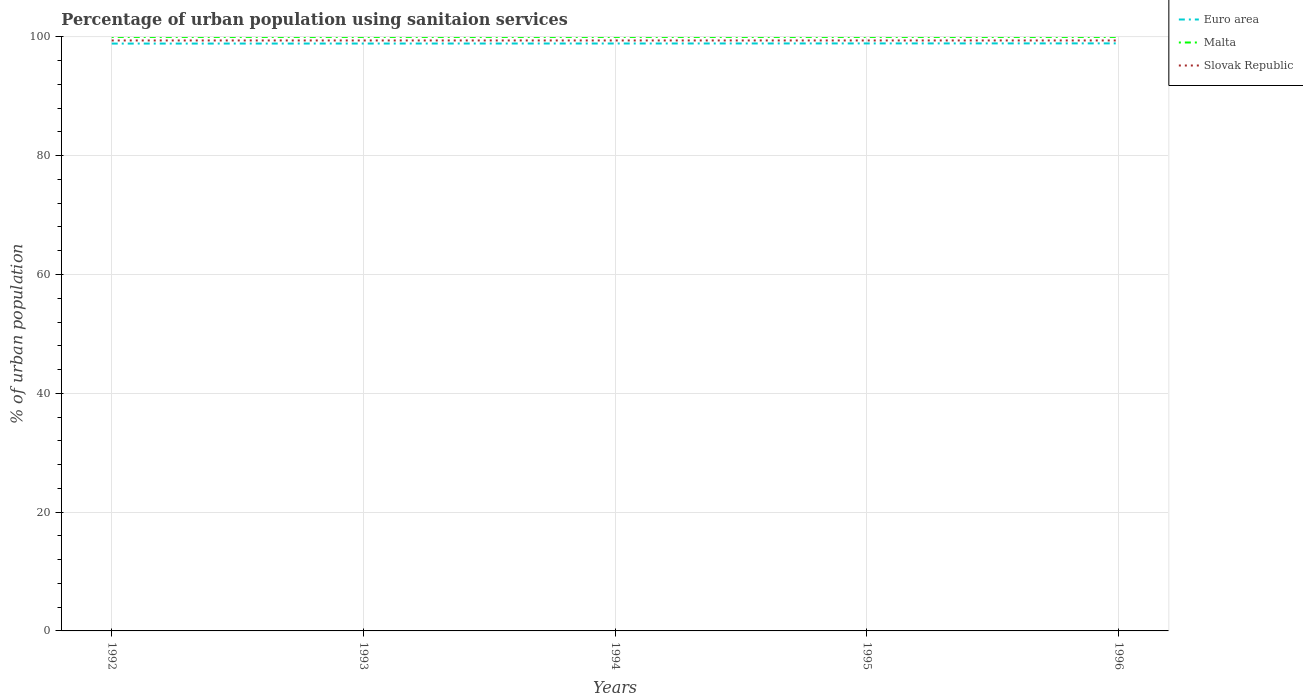Does the line corresponding to Slovak Republic intersect with the line corresponding to Malta?
Ensure brevity in your answer.  No. Across all years, what is the maximum percentage of urban population using sanitaion services in Euro area?
Provide a short and direct response. 98.88. What is the difference between the highest and the lowest percentage of urban population using sanitaion services in Euro area?
Offer a terse response. 2. Is the percentage of urban population using sanitaion services in Euro area strictly greater than the percentage of urban population using sanitaion services in Slovak Republic over the years?
Make the answer very short. Yes. How many years are there in the graph?
Make the answer very short. 5. Are the values on the major ticks of Y-axis written in scientific E-notation?
Offer a terse response. No. Does the graph contain any zero values?
Provide a short and direct response. No. Does the graph contain grids?
Your answer should be very brief. Yes. Where does the legend appear in the graph?
Give a very brief answer. Top right. What is the title of the graph?
Your answer should be compact. Percentage of urban population using sanitaion services. Does "Mauritania" appear as one of the legend labels in the graph?
Give a very brief answer. No. What is the label or title of the X-axis?
Make the answer very short. Years. What is the label or title of the Y-axis?
Ensure brevity in your answer.  % of urban population. What is the % of urban population of Euro area in 1992?
Offer a terse response. 98.88. What is the % of urban population of Slovak Republic in 1992?
Offer a very short reply. 99.4. What is the % of urban population in Euro area in 1993?
Offer a terse response. 98.89. What is the % of urban population of Slovak Republic in 1993?
Your answer should be compact. 99.4. What is the % of urban population of Euro area in 1994?
Make the answer very short. 98.89. What is the % of urban population of Slovak Republic in 1994?
Your answer should be very brief. 99.4. What is the % of urban population of Euro area in 1995?
Provide a short and direct response. 98.9. What is the % of urban population in Slovak Republic in 1995?
Your response must be concise. 99.4. What is the % of urban population of Euro area in 1996?
Offer a very short reply. 98.91. What is the % of urban population of Malta in 1996?
Give a very brief answer. 100. What is the % of urban population in Slovak Republic in 1996?
Make the answer very short. 99.4. Across all years, what is the maximum % of urban population of Euro area?
Make the answer very short. 98.91. Across all years, what is the maximum % of urban population in Slovak Republic?
Give a very brief answer. 99.4. Across all years, what is the minimum % of urban population in Euro area?
Offer a very short reply. 98.88. Across all years, what is the minimum % of urban population of Malta?
Your response must be concise. 100. Across all years, what is the minimum % of urban population of Slovak Republic?
Your answer should be very brief. 99.4. What is the total % of urban population in Euro area in the graph?
Your answer should be compact. 494.47. What is the total % of urban population of Malta in the graph?
Make the answer very short. 500. What is the total % of urban population of Slovak Republic in the graph?
Your answer should be compact. 497. What is the difference between the % of urban population of Euro area in 1992 and that in 1993?
Keep it short and to the point. -0.01. What is the difference between the % of urban population in Malta in 1992 and that in 1993?
Your answer should be compact. 0. What is the difference between the % of urban population in Euro area in 1992 and that in 1994?
Provide a succinct answer. -0.01. What is the difference between the % of urban population of Malta in 1992 and that in 1994?
Offer a very short reply. 0. What is the difference between the % of urban population in Slovak Republic in 1992 and that in 1994?
Ensure brevity in your answer.  0. What is the difference between the % of urban population of Euro area in 1992 and that in 1995?
Provide a short and direct response. -0.03. What is the difference between the % of urban population in Slovak Republic in 1992 and that in 1995?
Make the answer very short. 0. What is the difference between the % of urban population of Euro area in 1992 and that in 1996?
Offer a very short reply. -0.03. What is the difference between the % of urban population of Malta in 1992 and that in 1996?
Your answer should be compact. 0. What is the difference between the % of urban population in Slovak Republic in 1992 and that in 1996?
Your answer should be very brief. 0. What is the difference between the % of urban population in Euro area in 1993 and that in 1994?
Provide a succinct answer. -0.01. What is the difference between the % of urban population of Malta in 1993 and that in 1994?
Offer a very short reply. 0. What is the difference between the % of urban population in Euro area in 1993 and that in 1995?
Offer a very short reply. -0.02. What is the difference between the % of urban population in Slovak Republic in 1993 and that in 1995?
Your response must be concise. 0. What is the difference between the % of urban population of Euro area in 1993 and that in 1996?
Provide a short and direct response. -0.03. What is the difference between the % of urban population in Euro area in 1994 and that in 1995?
Offer a very short reply. -0.01. What is the difference between the % of urban population in Malta in 1994 and that in 1995?
Your answer should be compact. 0. What is the difference between the % of urban population in Euro area in 1994 and that in 1996?
Offer a very short reply. -0.02. What is the difference between the % of urban population in Malta in 1994 and that in 1996?
Ensure brevity in your answer.  0. What is the difference between the % of urban population of Euro area in 1995 and that in 1996?
Offer a terse response. -0.01. What is the difference between the % of urban population of Malta in 1995 and that in 1996?
Keep it short and to the point. 0. What is the difference between the % of urban population in Euro area in 1992 and the % of urban population in Malta in 1993?
Give a very brief answer. -1.12. What is the difference between the % of urban population of Euro area in 1992 and the % of urban population of Slovak Republic in 1993?
Offer a very short reply. -0.52. What is the difference between the % of urban population in Euro area in 1992 and the % of urban population in Malta in 1994?
Make the answer very short. -1.12. What is the difference between the % of urban population of Euro area in 1992 and the % of urban population of Slovak Republic in 1994?
Make the answer very short. -0.52. What is the difference between the % of urban population of Malta in 1992 and the % of urban population of Slovak Republic in 1994?
Offer a very short reply. 0.6. What is the difference between the % of urban population of Euro area in 1992 and the % of urban population of Malta in 1995?
Offer a terse response. -1.12. What is the difference between the % of urban population in Euro area in 1992 and the % of urban population in Slovak Republic in 1995?
Your answer should be very brief. -0.52. What is the difference between the % of urban population of Euro area in 1992 and the % of urban population of Malta in 1996?
Your response must be concise. -1.12. What is the difference between the % of urban population of Euro area in 1992 and the % of urban population of Slovak Republic in 1996?
Keep it short and to the point. -0.52. What is the difference between the % of urban population of Malta in 1992 and the % of urban population of Slovak Republic in 1996?
Provide a short and direct response. 0.6. What is the difference between the % of urban population in Euro area in 1993 and the % of urban population in Malta in 1994?
Keep it short and to the point. -1.11. What is the difference between the % of urban population of Euro area in 1993 and the % of urban population of Slovak Republic in 1994?
Provide a short and direct response. -0.51. What is the difference between the % of urban population of Malta in 1993 and the % of urban population of Slovak Republic in 1994?
Offer a terse response. 0.6. What is the difference between the % of urban population in Euro area in 1993 and the % of urban population in Malta in 1995?
Make the answer very short. -1.11. What is the difference between the % of urban population in Euro area in 1993 and the % of urban population in Slovak Republic in 1995?
Ensure brevity in your answer.  -0.51. What is the difference between the % of urban population of Euro area in 1993 and the % of urban population of Malta in 1996?
Give a very brief answer. -1.11. What is the difference between the % of urban population of Euro area in 1993 and the % of urban population of Slovak Republic in 1996?
Provide a short and direct response. -0.51. What is the difference between the % of urban population in Malta in 1993 and the % of urban population in Slovak Republic in 1996?
Give a very brief answer. 0.6. What is the difference between the % of urban population in Euro area in 1994 and the % of urban population in Malta in 1995?
Provide a short and direct response. -1.11. What is the difference between the % of urban population in Euro area in 1994 and the % of urban population in Slovak Republic in 1995?
Ensure brevity in your answer.  -0.51. What is the difference between the % of urban population of Malta in 1994 and the % of urban population of Slovak Republic in 1995?
Your answer should be compact. 0.6. What is the difference between the % of urban population in Euro area in 1994 and the % of urban population in Malta in 1996?
Make the answer very short. -1.11. What is the difference between the % of urban population of Euro area in 1994 and the % of urban population of Slovak Republic in 1996?
Provide a succinct answer. -0.51. What is the difference between the % of urban population in Euro area in 1995 and the % of urban population in Malta in 1996?
Offer a terse response. -1.1. What is the difference between the % of urban population of Euro area in 1995 and the % of urban population of Slovak Republic in 1996?
Provide a short and direct response. -0.5. What is the average % of urban population of Euro area per year?
Give a very brief answer. 98.89. What is the average % of urban population of Slovak Republic per year?
Provide a short and direct response. 99.4. In the year 1992, what is the difference between the % of urban population in Euro area and % of urban population in Malta?
Offer a terse response. -1.12. In the year 1992, what is the difference between the % of urban population in Euro area and % of urban population in Slovak Republic?
Keep it short and to the point. -0.52. In the year 1993, what is the difference between the % of urban population in Euro area and % of urban population in Malta?
Your response must be concise. -1.11. In the year 1993, what is the difference between the % of urban population in Euro area and % of urban population in Slovak Republic?
Offer a very short reply. -0.51. In the year 1993, what is the difference between the % of urban population of Malta and % of urban population of Slovak Republic?
Provide a succinct answer. 0.6. In the year 1994, what is the difference between the % of urban population of Euro area and % of urban population of Malta?
Your answer should be compact. -1.11. In the year 1994, what is the difference between the % of urban population of Euro area and % of urban population of Slovak Republic?
Offer a very short reply. -0.51. In the year 1994, what is the difference between the % of urban population in Malta and % of urban population in Slovak Republic?
Your answer should be compact. 0.6. In the year 1995, what is the difference between the % of urban population in Euro area and % of urban population in Malta?
Keep it short and to the point. -1.1. In the year 1995, what is the difference between the % of urban population of Euro area and % of urban population of Slovak Republic?
Your answer should be compact. -0.5. In the year 1995, what is the difference between the % of urban population of Malta and % of urban population of Slovak Republic?
Make the answer very short. 0.6. In the year 1996, what is the difference between the % of urban population in Euro area and % of urban population in Malta?
Your answer should be compact. -1.09. In the year 1996, what is the difference between the % of urban population of Euro area and % of urban population of Slovak Republic?
Keep it short and to the point. -0.49. What is the ratio of the % of urban population of Slovak Republic in 1992 to that in 1993?
Make the answer very short. 1. What is the ratio of the % of urban population in Euro area in 1992 to that in 1994?
Your answer should be compact. 1. What is the ratio of the % of urban population of Slovak Republic in 1992 to that in 1994?
Your response must be concise. 1. What is the ratio of the % of urban population of Euro area in 1992 to that in 1995?
Give a very brief answer. 1. What is the ratio of the % of urban population in Malta in 1992 to that in 1995?
Make the answer very short. 1. What is the ratio of the % of urban population of Slovak Republic in 1992 to that in 1995?
Your response must be concise. 1. What is the ratio of the % of urban population of Euro area in 1992 to that in 1996?
Keep it short and to the point. 1. What is the ratio of the % of urban population of Malta in 1992 to that in 1996?
Provide a short and direct response. 1. What is the ratio of the % of urban population of Euro area in 1993 to that in 1994?
Ensure brevity in your answer.  1. What is the ratio of the % of urban population of Euro area in 1993 to that in 1995?
Give a very brief answer. 1. What is the ratio of the % of urban population in Malta in 1993 to that in 1996?
Offer a terse response. 1. What is the ratio of the % of urban population of Slovak Republic in 1993 to that in 1996?
Your response must be concise. 1. What is the ratio of the % of urban population in Malta in 1994 to that in 1996?
Ensure brevity in your answer.  1. What is the ratio of the % of urban population in Euro area in 1995 to that in 1996?
Provide a short and direct response. 1. What is the ratio of the % of urban population in Slovak Republic in 1995 to that in 1996?
Make the answer very short. 1. What is the difference between the highest and the second highest % of urban population of Euro area?
Provide a short and direct response. 0.01. What is the difference between the highest and the second highest % of urban population of Malta?
Offer a very short reply. 0. What is the difference between the highest and the second highest % of urban population in Slovak Republic?
Your answer should be compact. 0. What is the difference between the highest and the lowest % of urban population of Euro area?
Provide a succinct answer. 0.03. What is the difference between the highest and the lowest % of urban population in Slovak Republic?
Your answer should be very brief. 0. 